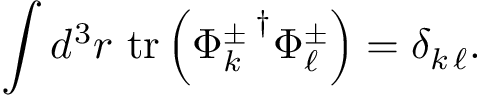Convert formula to latex. <formula><loc_0><loc_0><loc_500><loc_500>\int d ^ { 3 } r t r \left ( { \Phi _ { k } ^ { \pm } \, } ^ { \dagger } \Phi _ { \ell } ^ { \pm } \right ) = \delta _ { k \, \ell } .</formula> 